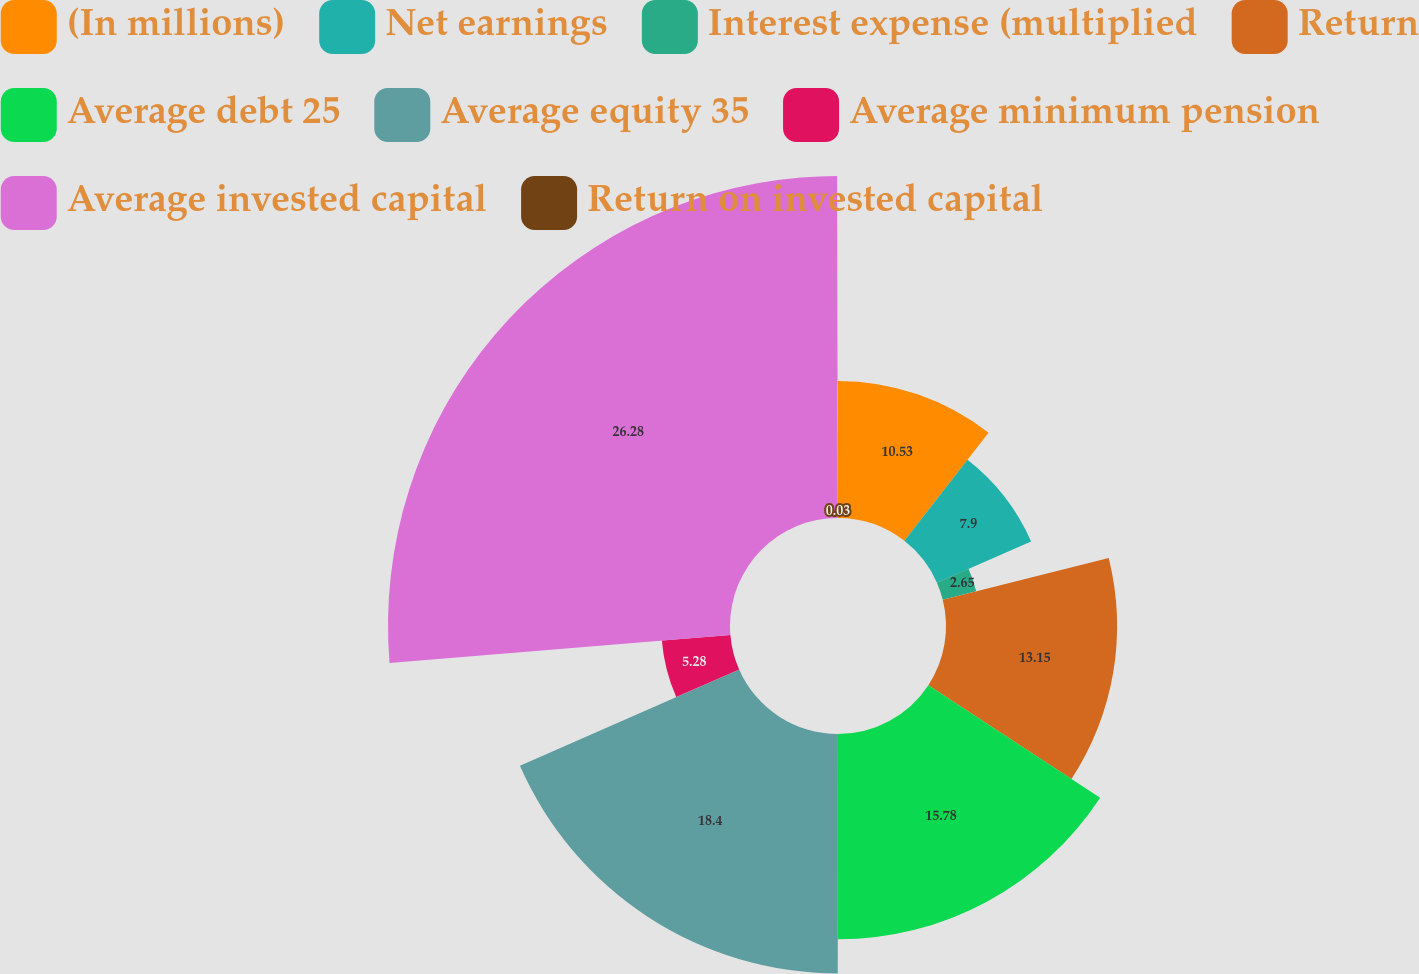Convert chart. <chart><loc_0><loc_0><loc_500><loc_500><pie_chart><fcel>(In millions)<fcel>Net earnings<fcel>Interest expense (multiplied<fcel>Return<fcel>Average debt 25<fcel>Average equity 35<fcel>Average minimum pension<fcel>Average invested capital<fcel>Return on invested capital<nl><fcel>10.53%<fcel>7.9%<fcel>2.65%<fcel>13.15%<fcel>15.78%<fcel>18.4%<fcel>5.28%<fcel>26.28%<fcel>0.03%<nl></chart> 